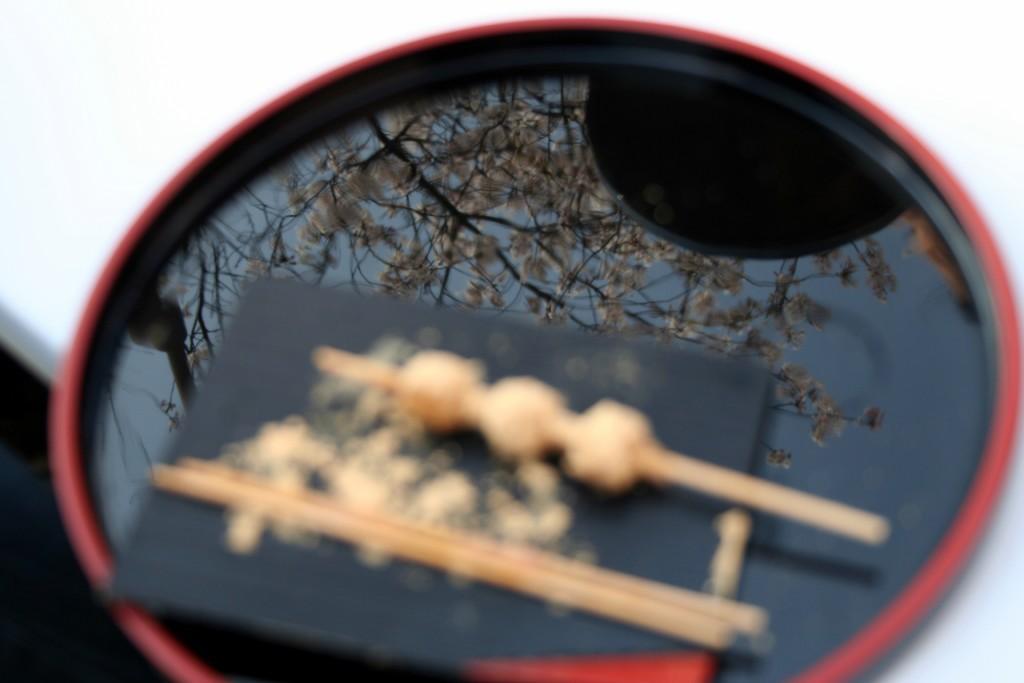Describe this image in one or two sentences. In this image there is a bowl filled with water and tree is shown as mirror image in it and there are two chopsticks placed on it. 